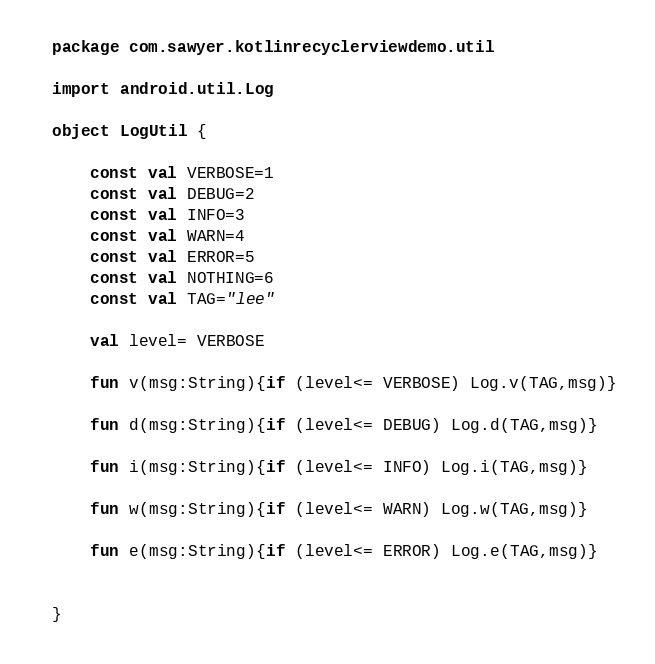<code> <loc_0><loc_0><loc_500><loc_500><_Kotlin_>package com.sawyer.kotlinrecyclerviewdemo.util

import android.util.Log

object LogUtil {

    const val VERBOSE=1
    const val DEBUG=2
    const val INFO=3
    const val WARN=4
    const val ERROR=5
    const val NOTHING=6
    const val TAG="lee"

    val level= VERBOSE

    fun v(msg:String){if (level<= VERBOSE) Log.v(TAG,msg)}

    fun d(msg:String){if (level<= DEBUG) Log.d(TAG,msg)}

    fun i(msg:String){if (level<= INFO) Log.i(TAG,msg)}

    fun w(msg:String){if (level<= WARN) Log.w(TAG,msg)}

    fun e(msg:String){if (level<= ERROR) Log.e(TAG,msg)}


}</code> 